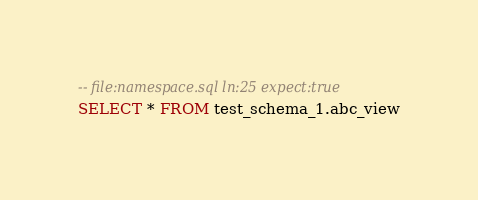Convert code to text. <code><loc_0><loc_0><loc_500><loc_500><_SQL_>-- file:namespace.sql ln:25 expect:true
SELECT * FROM test_schema_1.abc_view
</code> 